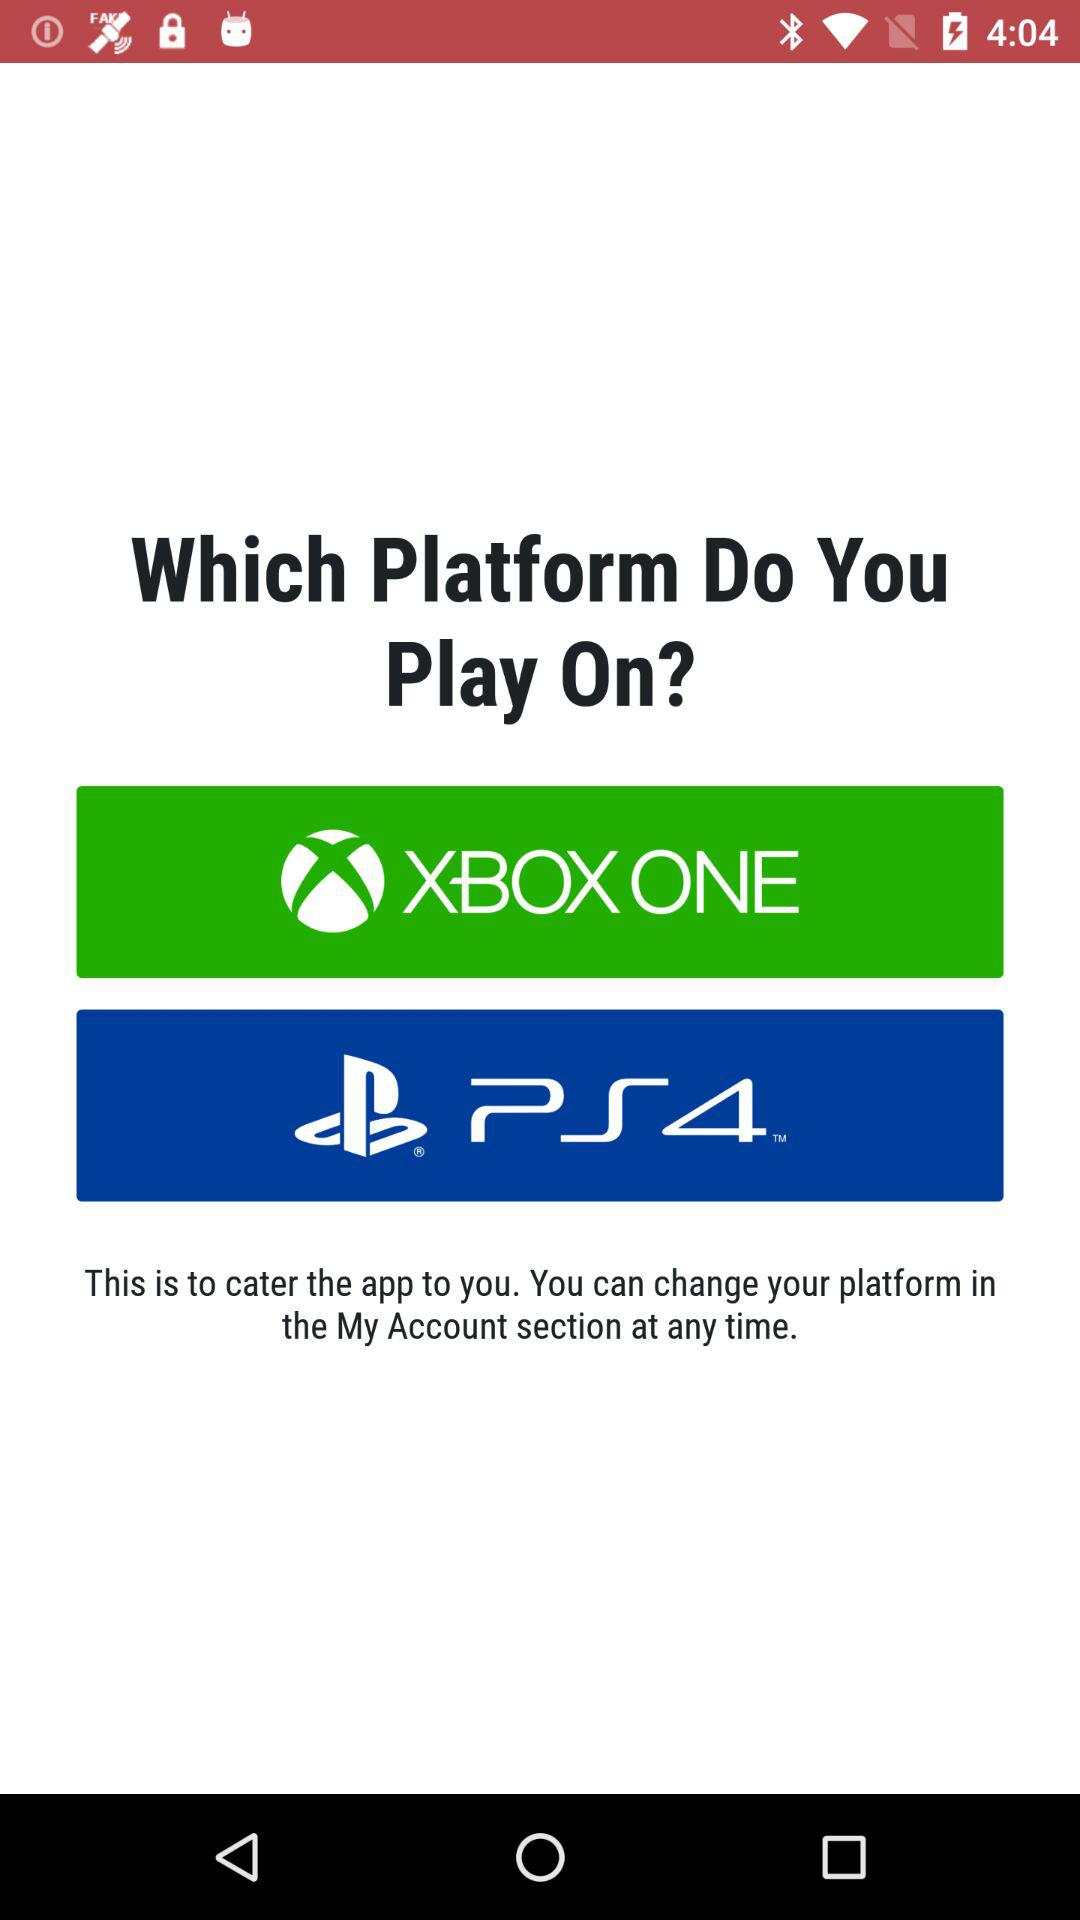What are the platform options that we can use? The platform options are "XBOX ONE" and "PS4". 